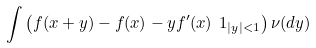Convert formula to latex. <formula><loc_0><loc_0><loc_500><loc_500>\int \left ( f ( x + y ) - f ( x ) - y f ^ { \prime } ( x ) \ 1 _ { | y | < 1 } \right ) \nu ( d y )</formula> 